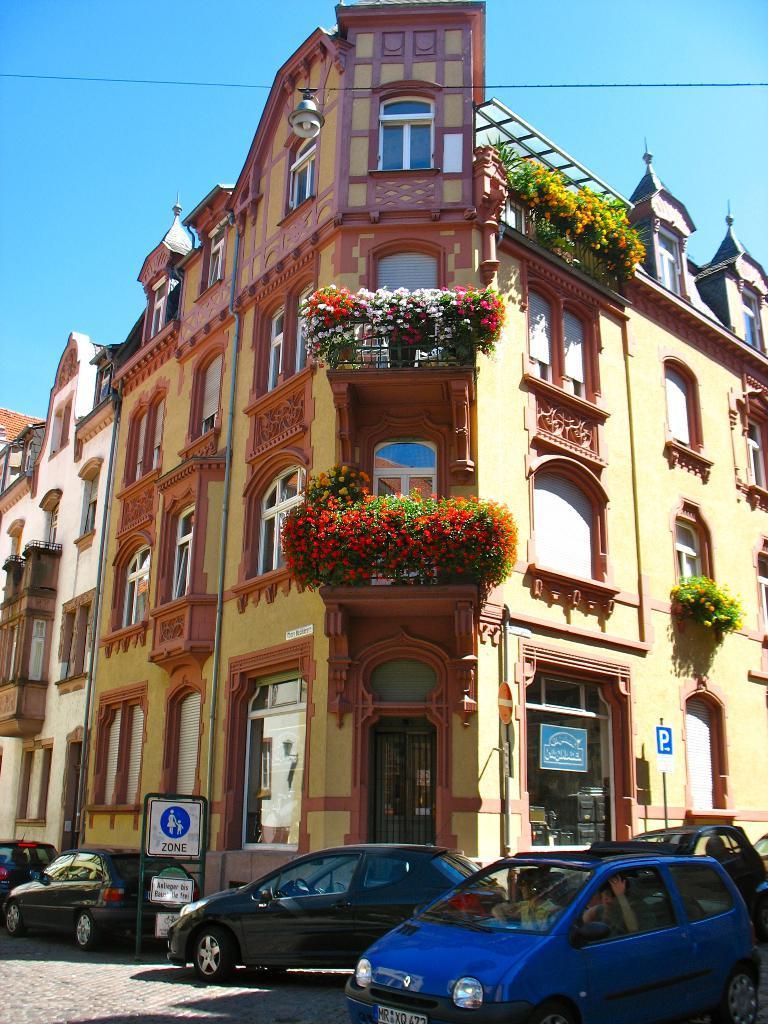How would you summarize this image in a sentence or two? In this image in the center there are cars and there is a board with some text written on it. In the background there are buildings and there are flowers on the building and there is a board hanging on the wall of the building. 